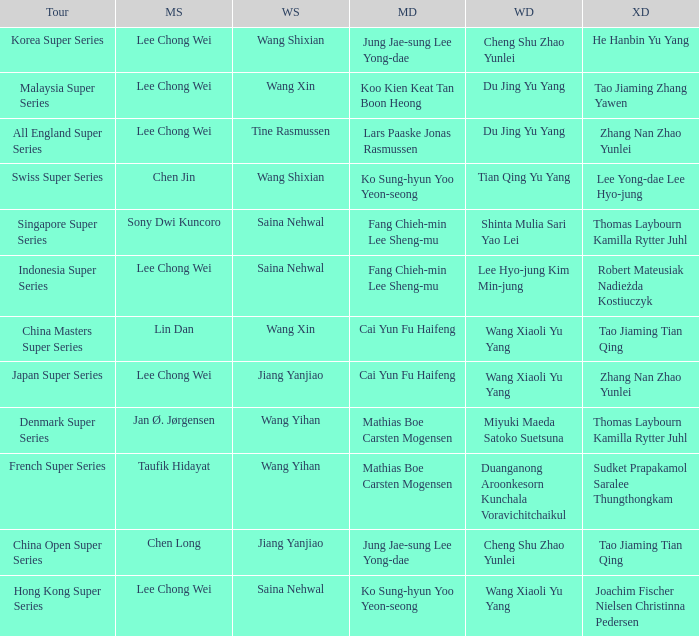Who is the women's doubles when the mixed doubles are sudket prapakamol saralee thungthongkam? Duanganong Aroonkesorn Kunchala Voravichitchaikul. 